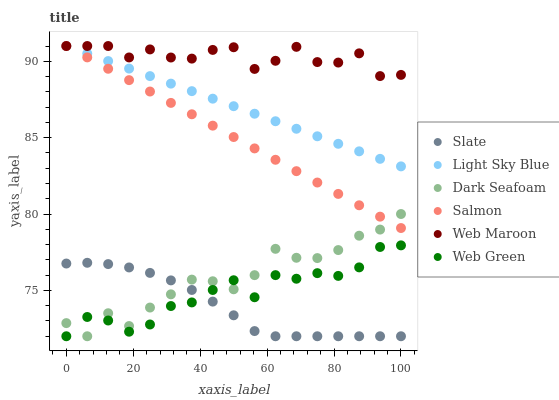Does Slate have the minimum area under the curve?
Answer yes or no. Yes. Does Web Maroon have the maximum area under the curve?
Answer yes or no. Yes. Does Web Maroon have the minimum area under the curve?
Answer yes or no. No. Does Slate have the maximum area under the curve?
Answer yes or no. No. Is Salmon the smoothest?
Answer yes or no. Yes. Is Dark Seafoam the roughest?
Answer yes or no. Yes. Is Slate the smoothest?
Answer yes or no. No. Is Slate the roughest?
Answer yes or no. No. Does Slate have the lowest value?
Answer yes or no. Yes. Does Web Maroon have the lowest value?
Answer yes or no. No. Does Light Sky Blue have the highest value?
Answer yes or no. Yes. Does Slate have the highest value?
Answer yes or no. No. Is Slate less than Web Maroon?
Answer yes or no. Yes. Is Salmon greater than Slate?
Answer yes or no. Yes. Does Salmon intersect Web Maroon?
Answer yes or no. Yes. Is Salmon less than Web Maroon?
Answer yes or no. No. Is Salmon greater than Web Maroon?
Answer yes or no. No. Does Slate intersect Web Maroon?
Answer yes or no. No. 